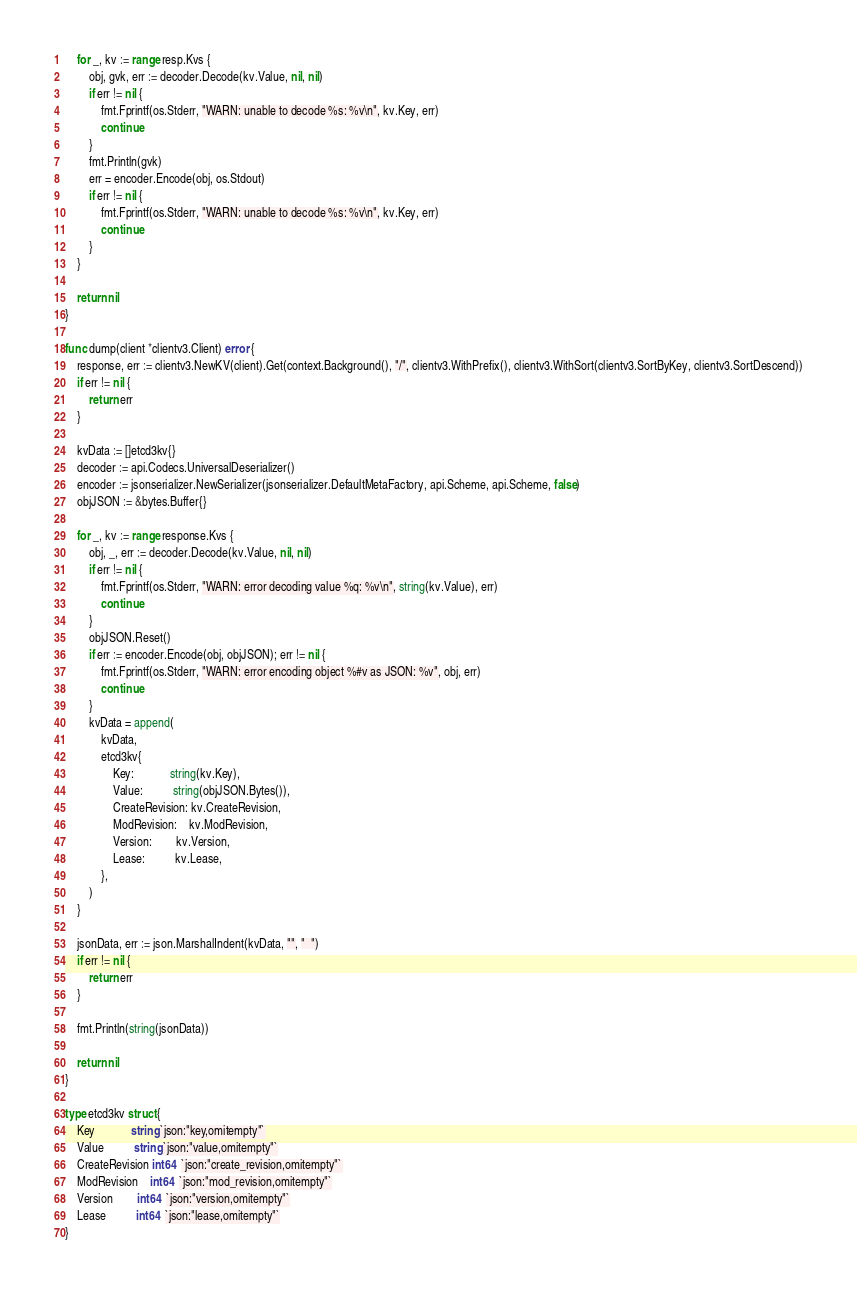<code> <loc_0><loc_0><loc_500><loc_500><_Go_>
	for _, kv := range resp.Kvs {
		obj, gvk, err := decoder.Decode(kv.Value, nil, nil)
		if err != nil {
			fmt.Fprintf(os.Stderr, "WARN: unable to decode %s: %v\n", kv.Key, err)
			continue
		}
		fmt.Println(gvk)
		err = encoder.Encode(obj, os.Stdout)
		if err != nil {
			fmt.Fprintf(os.Stderr, "WARN: unable to decode %s: %v\n", kv.Key, err)
			continue
		}
	}

	return nil
}

func dump(client *clientv3.Client) error {
	response, err := clientv3.NewKV(client).Get(context.Background(), "/", clientv3.WithPrefix(), clientv3.WithSort(clientv3.SortByKey, clientv3.SortDescend))
	if err != nil {
		return err
	}

	kvData := []etcd3kv{}
	decoder := api.Codecs.UniversalDeserializer()
	encoder := jsonserializer.NewSerializer(jsonserializer.DefaultMetaFactory, api.Scheme, api.Scheme, false)
	objJSON := &bytes.Buffer{}

	for _, kv := range response.Kvs {
		obj, _, err := decoder.Decode(kv.Value, nil, nil)
		if err != nil {
			fmt.Fprintf(os.Stderr, "WARN: error decoding value %q: %v\n", string(kv.Value), err)
			continue
		}
		objJSON.Reset()
		if err := encoder.Encode(obj, objJSON); err != nil {
			fmt.Fprintf(os.Stderr, "WARN: error encoding object %#v as JSON: %v", obj, err)
			continue
		}
		kvData = append(
			kvData,
			etcd3kv{
				Key:            string(kv.Key),
				Value:          string(objJSON.Bytes()),
				CreateRevision: kv.CreateRevision,
				ModRevision:    kv.ModRevision,
				Version:        kv.Version,
				Lease:          kv.Lease,
			},
		)
	}

	jsonData, err := json.MarshalIndent(kvData, "", "  ")
	if err != nil {
		return err
	}

	fmt.Println(string(jsonData))

	return nil
}

type etcd3kv struct {
	Key            string `json:"key,omitempty"`
	Value          string `json:"value,omitempty"`
	CreateRevision int64  `json:"create_revision,omitempty"`
	ModRevision    int64  `json:"mod_revision,omitempty"`
	Version        int64  `json:"version,omitempty"`
	Lease          int64  `json:"lease,omitempty"`
}
</code> 